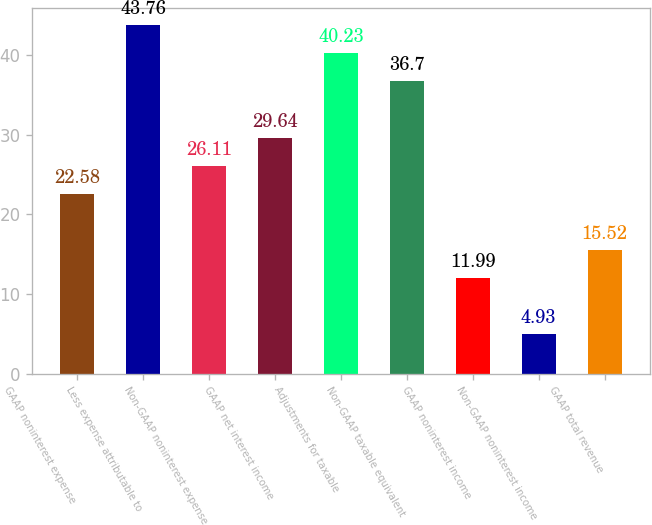Convert chart to OTSL. <chart><loc_0><loc_0><loc_500><loc_500><bar_chart><fcel>GAAP noninterest expense<fcel>Less expense attributable to<fcel>Non-GAAP noninterest expense<fcel>GAAP net interest income<fcel>Adjustments for taxable<fcel>Non-GAAP taxable equivalent<fcel>GAAP noninterest income<fcel>Non-GAAP noninterest income<fcel>GAAP total revenue<nl><fcel>22.58<fcel>43.76<fcel>26.11<fcel>29.64<fcel>40.23<fcel>36.7<fcel>11.99<fcel>4.93<fcel>15.52<nl></chart> 